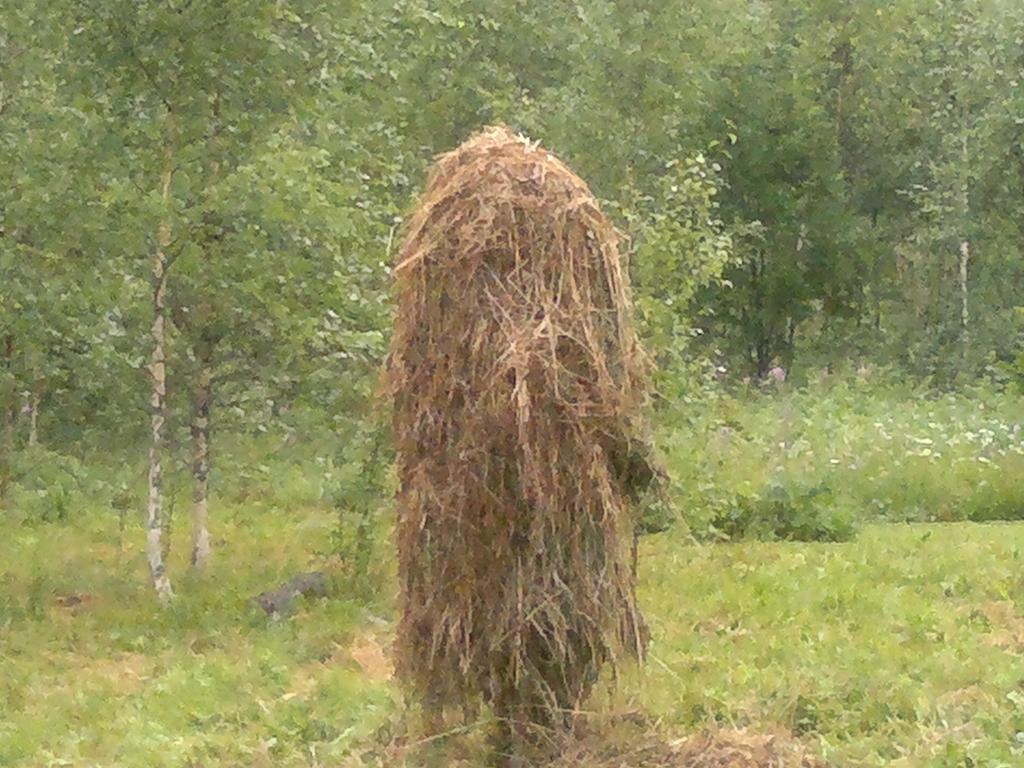What is the main feature in the center of the image? There is dry grass in the center of the image. What can be seen in the background of the image? There are trees in the background of the image. What type of vegetation is present at the bottom of the image? There is grass at the bottom of the image. What type of leather can be seen covering the oven in the image? There is no oven or leather present in the image. 